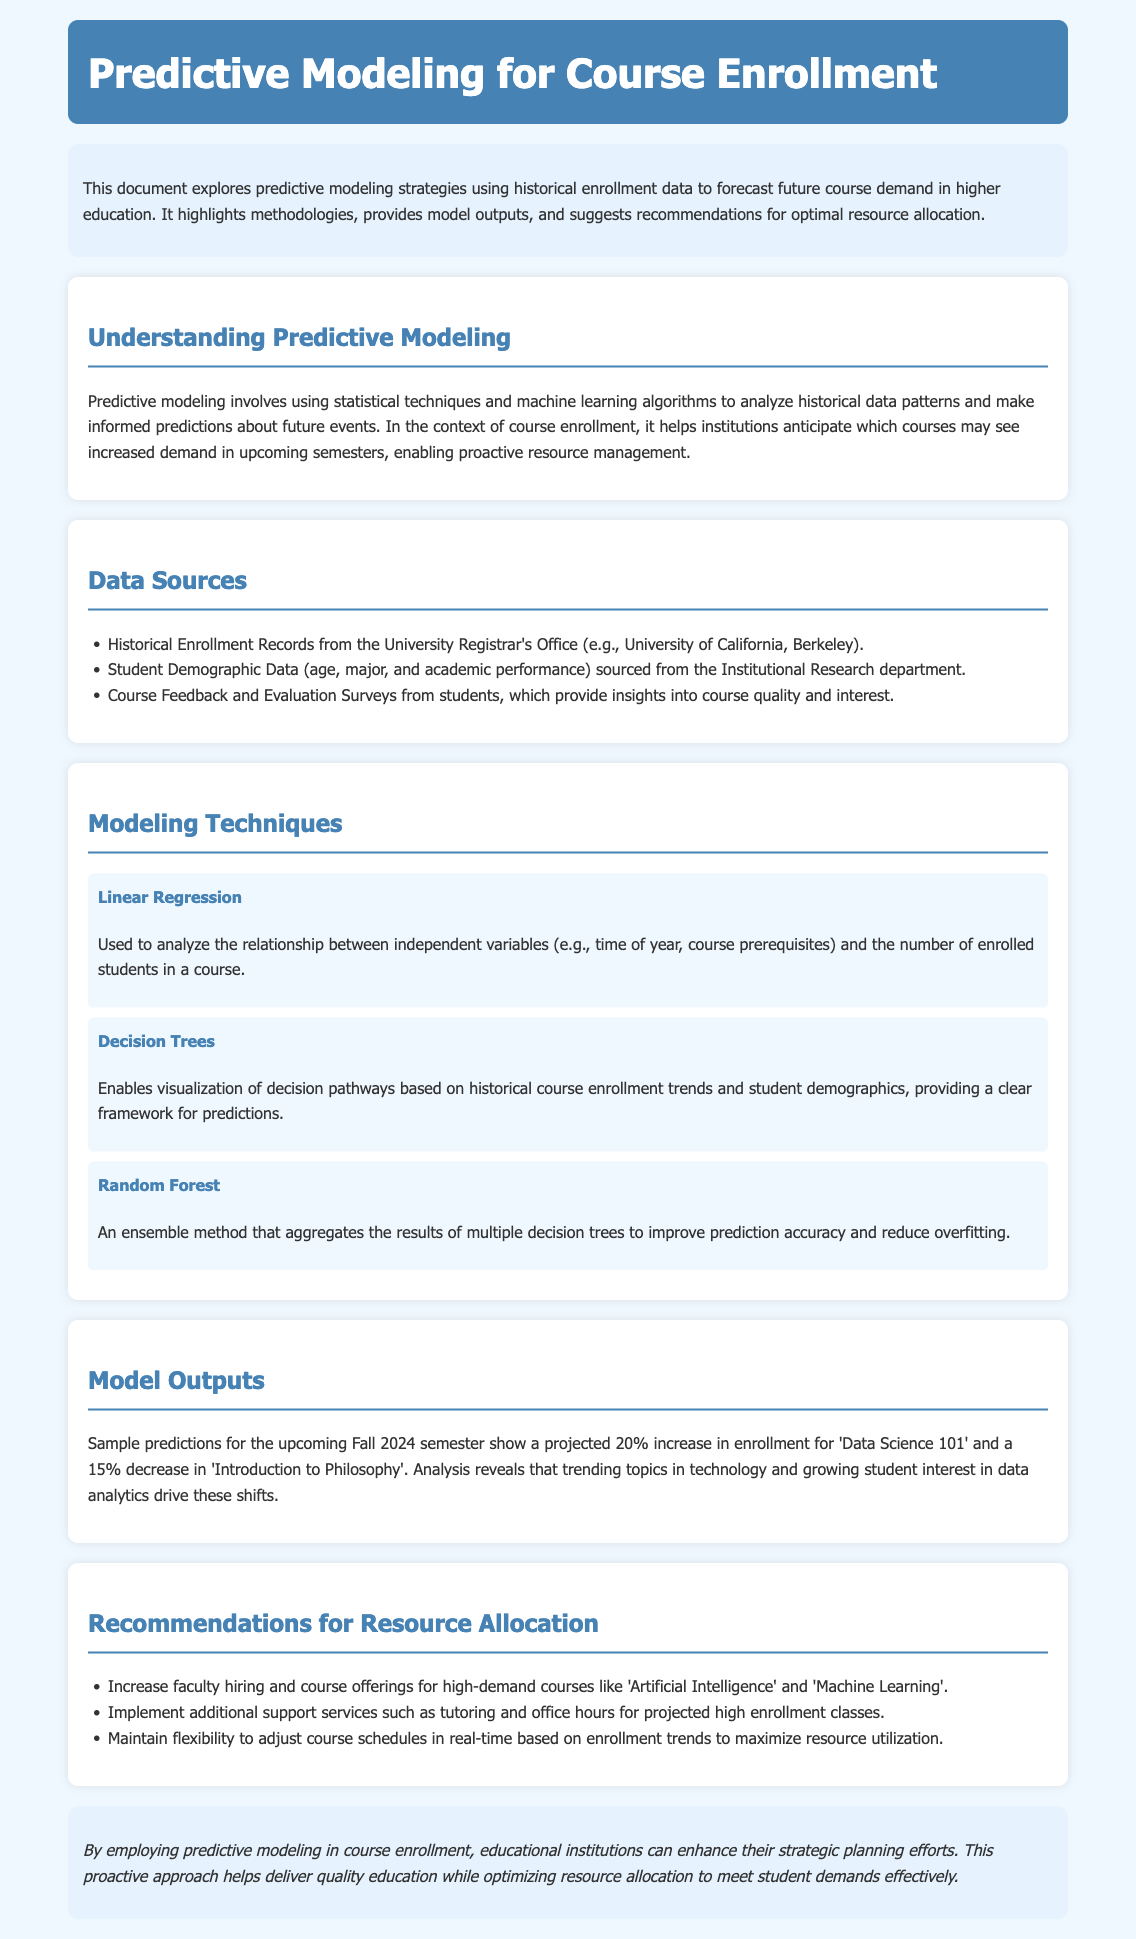What is the title of the document? The title of the document is indicated at the top header of the rendered page.
Answer: Predictive Modeling for Course Enrollment What is the projected increase in enrollment for 'Data Science 101'? The increase is mentioned in the model outputs section of the document.
Answer: 20% Which modeling technique uses an ensemble method? The use of an ensemble method is described in the Modeling Techniques section.
Answer: Random Forest What data source is mentioned related to student demographics? The document lists data sources in a specific section; one of them pertains to demographic data.
Answer: Student Demographic Data What is a recommendation for resource allocation? Recommendations for resource allocation are listed in their respective section of the document.
Answer: Increase faculty hiring What statistical technique analyzes the relationship between variables and enrollment? The document specifies this technique as part of the modeling techniques discussion.
Answer: Linear Regression What course is projected to see a 15% decrease in enrollment? This course is specifically mentioned in the model outputs section of the document.
Answer: Introduction to Philosophy What department provides course feedback and evaluation surveys? The source of this data is identified in the data sources section.
Answer: Institutional Research What is the main purpose of predictive modeling in course enrollment? The purpose is outlined in the understanding predictive modeling section.
Answer: Anticipate future course demand 